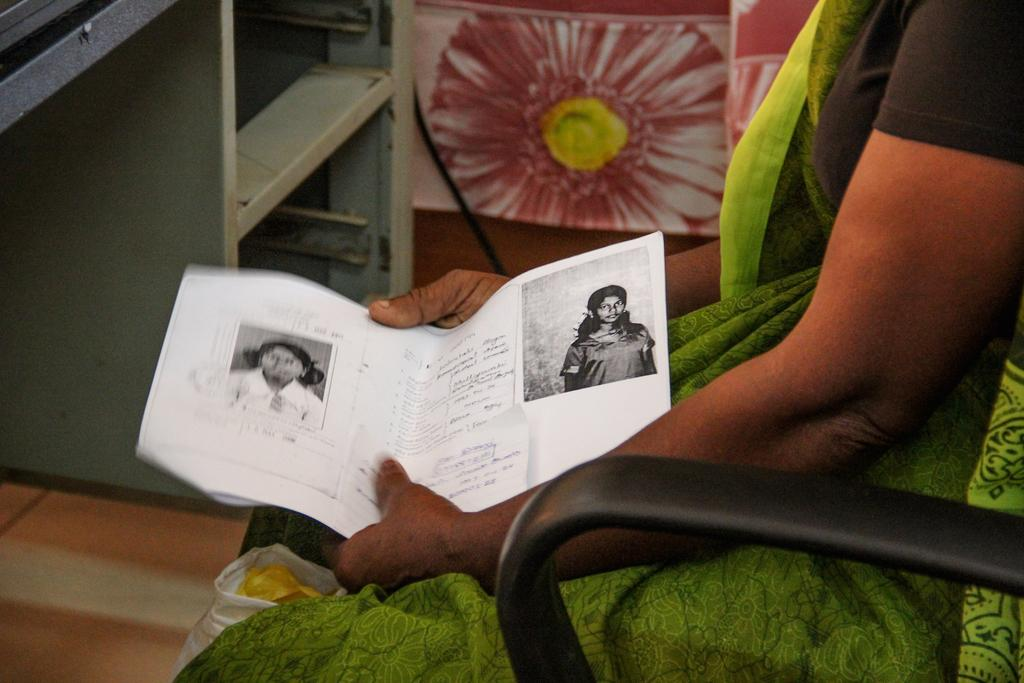What is the lady in the image doing? The lady is sitting on a chair and holding papers and a cover. What can be seen in the background of the image? There is a stand in the background. Are there any decorative elements in the image? Yes, there is a painting of a flower in the image. What is the profit generated by the wind in the image? There is no mention of wind or profit in the image, so this question cannot be answered. 